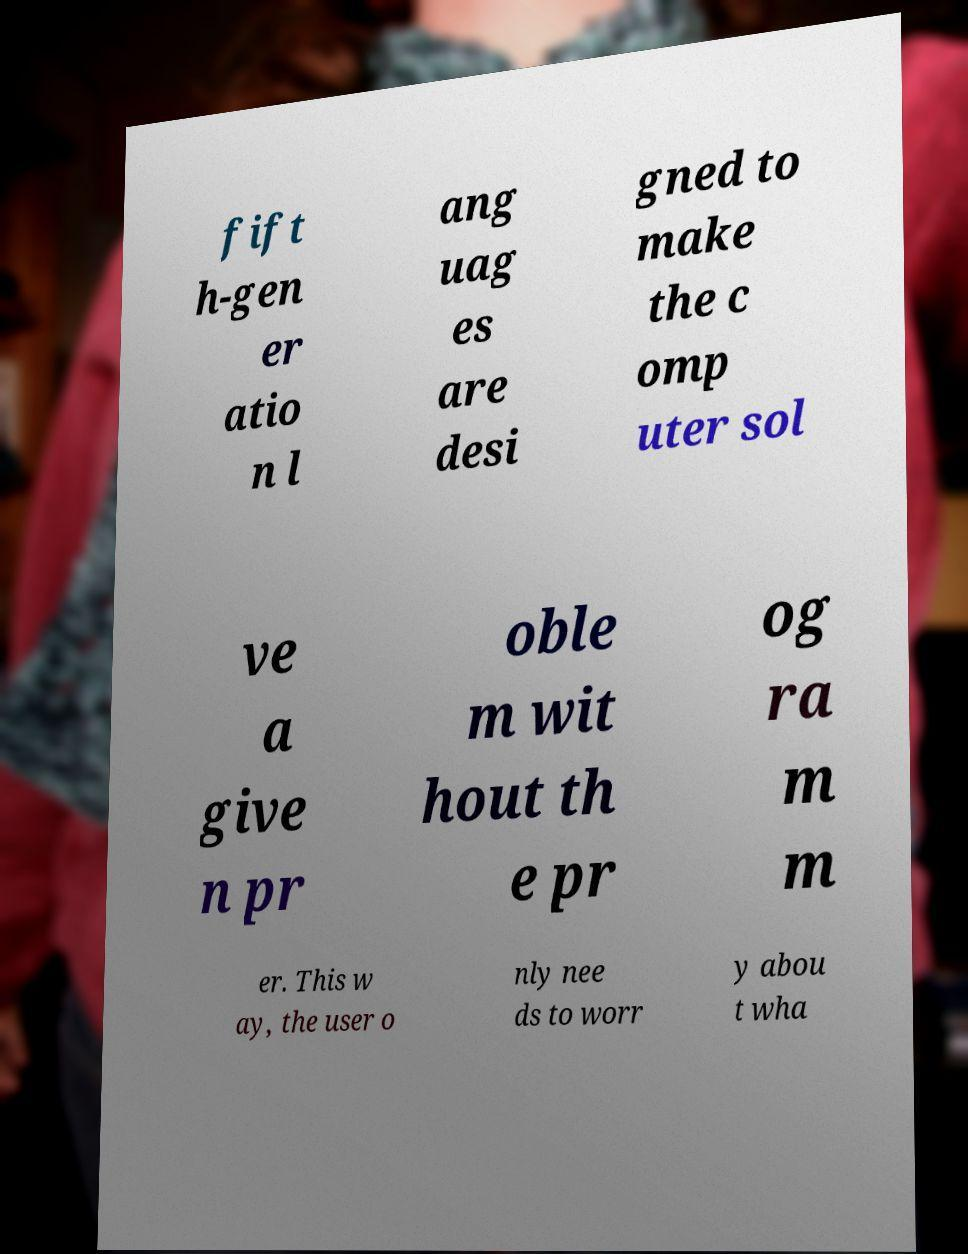For documentation purposes, I need the text within this image transcribed. Could you provide that? fift h-gen er atio n l ang uag es are desi gned to make the c omp uter sol ve a give n pr oble m wit hout th e pr og ra m m er. This w ay, the user o nly nee ds to worr y abou t wha 